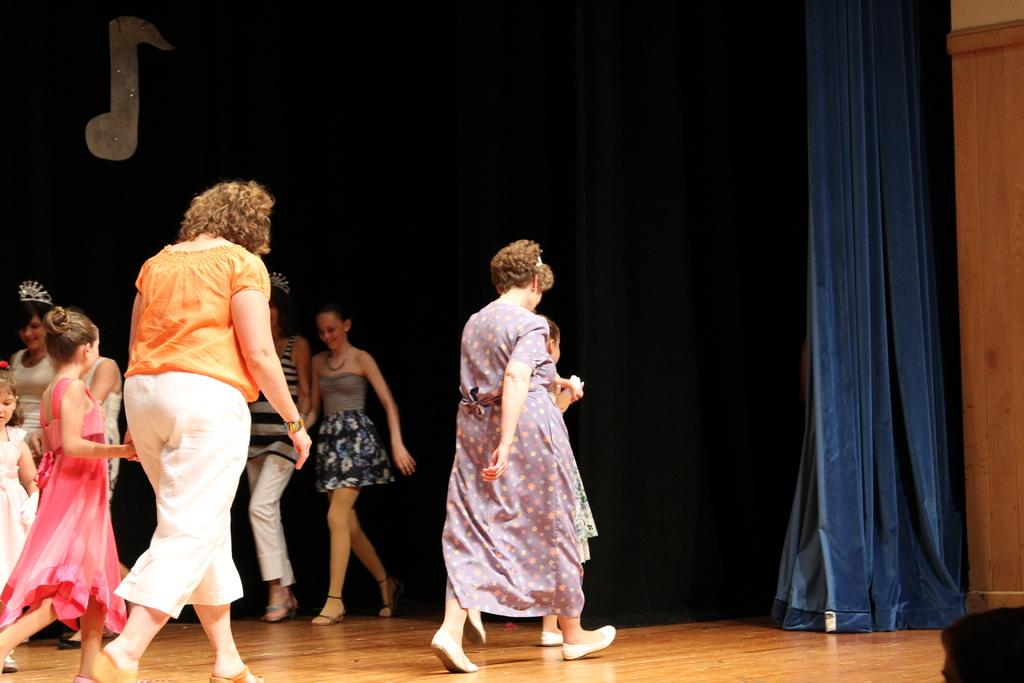What is happening in the image? There is a group of persons standing on the stage. Who are the people on the stage? There are children standing in the image. What can be seen behind the children on the stage? There is a blue curtain in the image. How many babies are holding icicles in the image? There are no babies or icicles present in the image. 